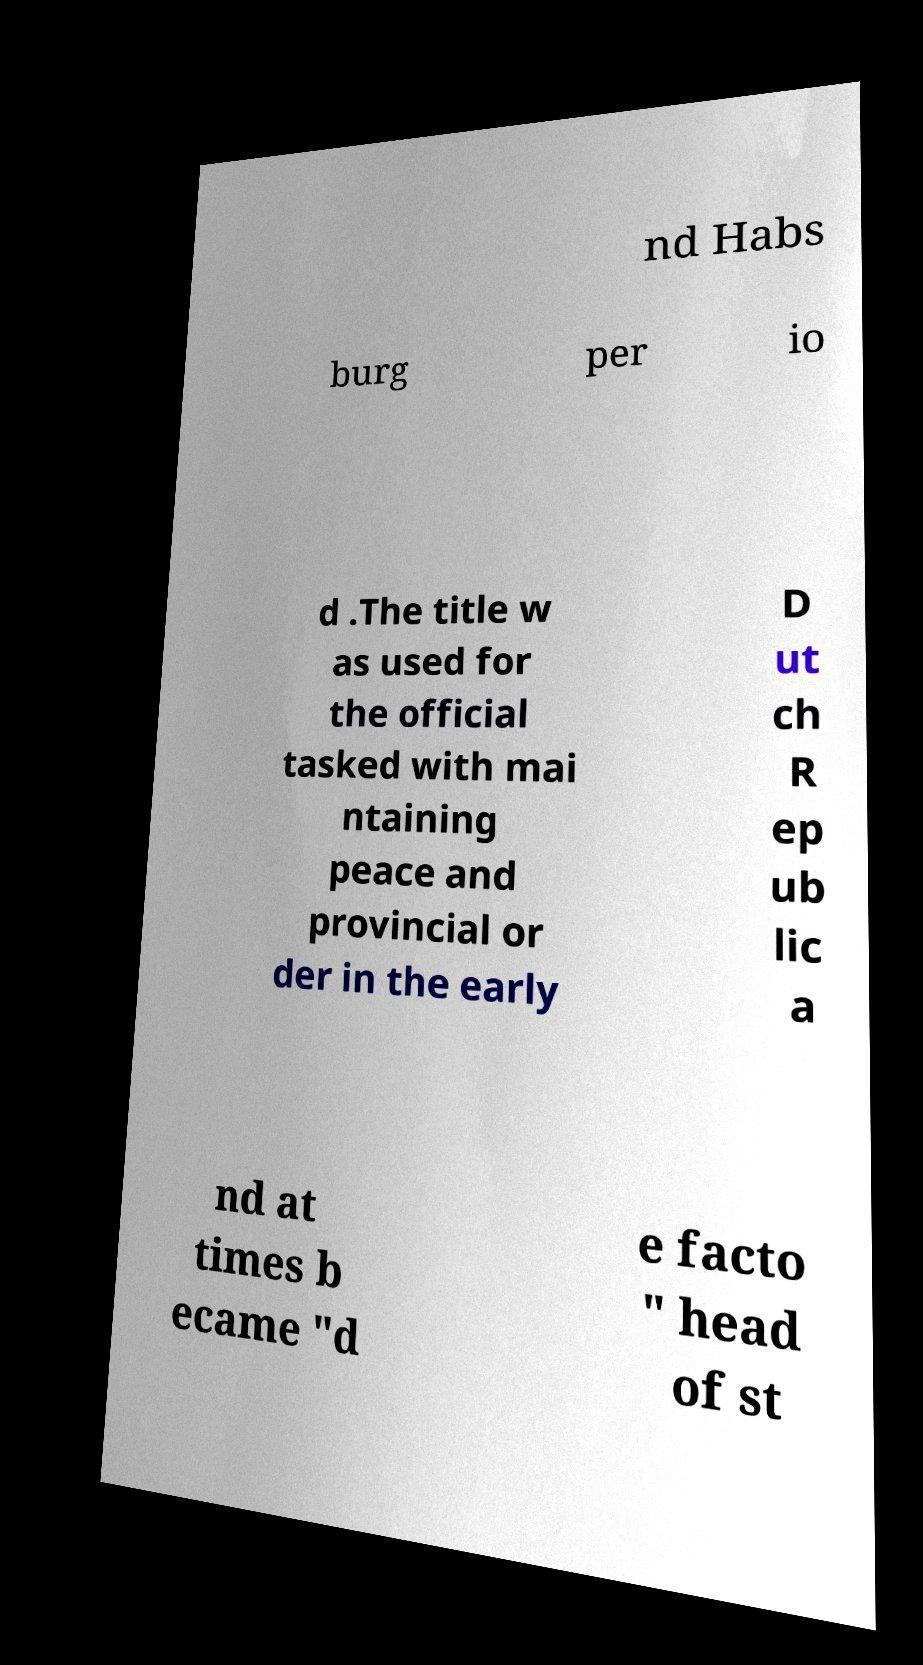Can you accurately transcribe the text from the provided image for me? nd Habs burg per io d .The title w as used for the official tasked with mai ntaining peace and provincial or der in the early D ut ch R ep ub lic a nd at times b ecame "d e facto " head of st 